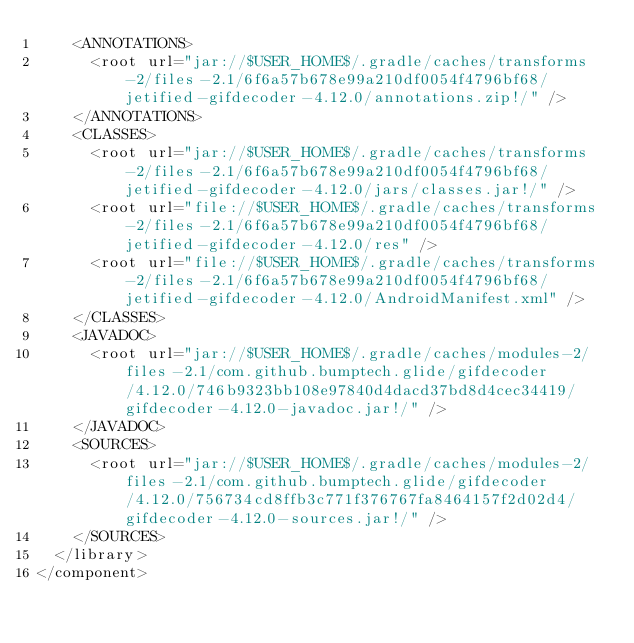Convert code to text. <code><loc_0><loc_0><loc_500><loc_500><_XML_>    <ANNOTATIONS>
      <root url="jar://$USER_HOME$/.gradle/caches/transforms-2/files-2.1/6f6a57b678e99a210df0054f4796bf68/jetified-gifdecoder-4.12.0/annotations.zip!/" />
    </ANNOTATIONS>
    <CLASSES>
      <root url="jar://$USER_HOME$/.gradle/caches/transforms-2/files-2.1/6f6a57b678e99a210df0054f4796bf68/jetified-gifdecoder-4.12.0/jars/classes.jar!/" />
      <root url="file://$USER_HOME$/.gradle/caches/transforms-2/files-2.1/6f6a57b678e99a210df0054f4796bf68/jetified-gifdecoder-4.12.0/res" />
      <root url="file://$USER_HOME$/.gradle/caches/transforms-2/files-2.1/6f6a57b678e99a210df0054f4796bf68/jetified-gifdecoder-4.12.0/AndroidManifest.xml" />
    </CLASSES>
    <JAVADOC>
      <root url="jar://$USER_HOME$/.gradle/caches/modules-2/files-2.1/com.github.bumptech.glide/gifdecoder/4.12.0/746b9323bb108e97840d4dacd37bd8d4cec34419/gifdecoder-4.12.0-javadoc.jar!/" />
    </JAVADOC>
    <SOURCES>
      <root url="jar://$USER_HOME$/.gradle/caches/modules-2/files-2.1/com.github.bumptech.glide/gifdecoder/4.12.0/756734cd8ffb3c771f376767fa8464157f2d02d4/gifdecoder-4.12.0-sources.jar!/" />
    </SOURCES>
  </library>
</component></code> 